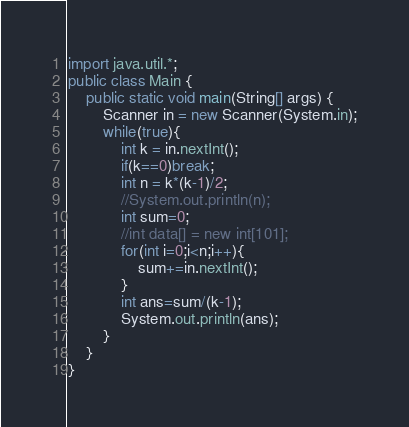<code> <loc_0><loc_0><loc_500><loc_500><_Java_>import java.util.*;
public class Main {
	public static void main(String[] args) {
		Scanner in = new Scanner(System.in);
		while(true){
			int k = in.nextInt();
			if(k==0)break;
			int n = k*(k-1)/2;
			//System.out.println(n);
			int sum=0;
			//int data[] = new int[101];
			for(int i=0;i<n;i++){
				sum+=in.nextInt();
			}
			int ans=sum/(k-1);
			System.out.println(ans);
		}
	}
}</code> 